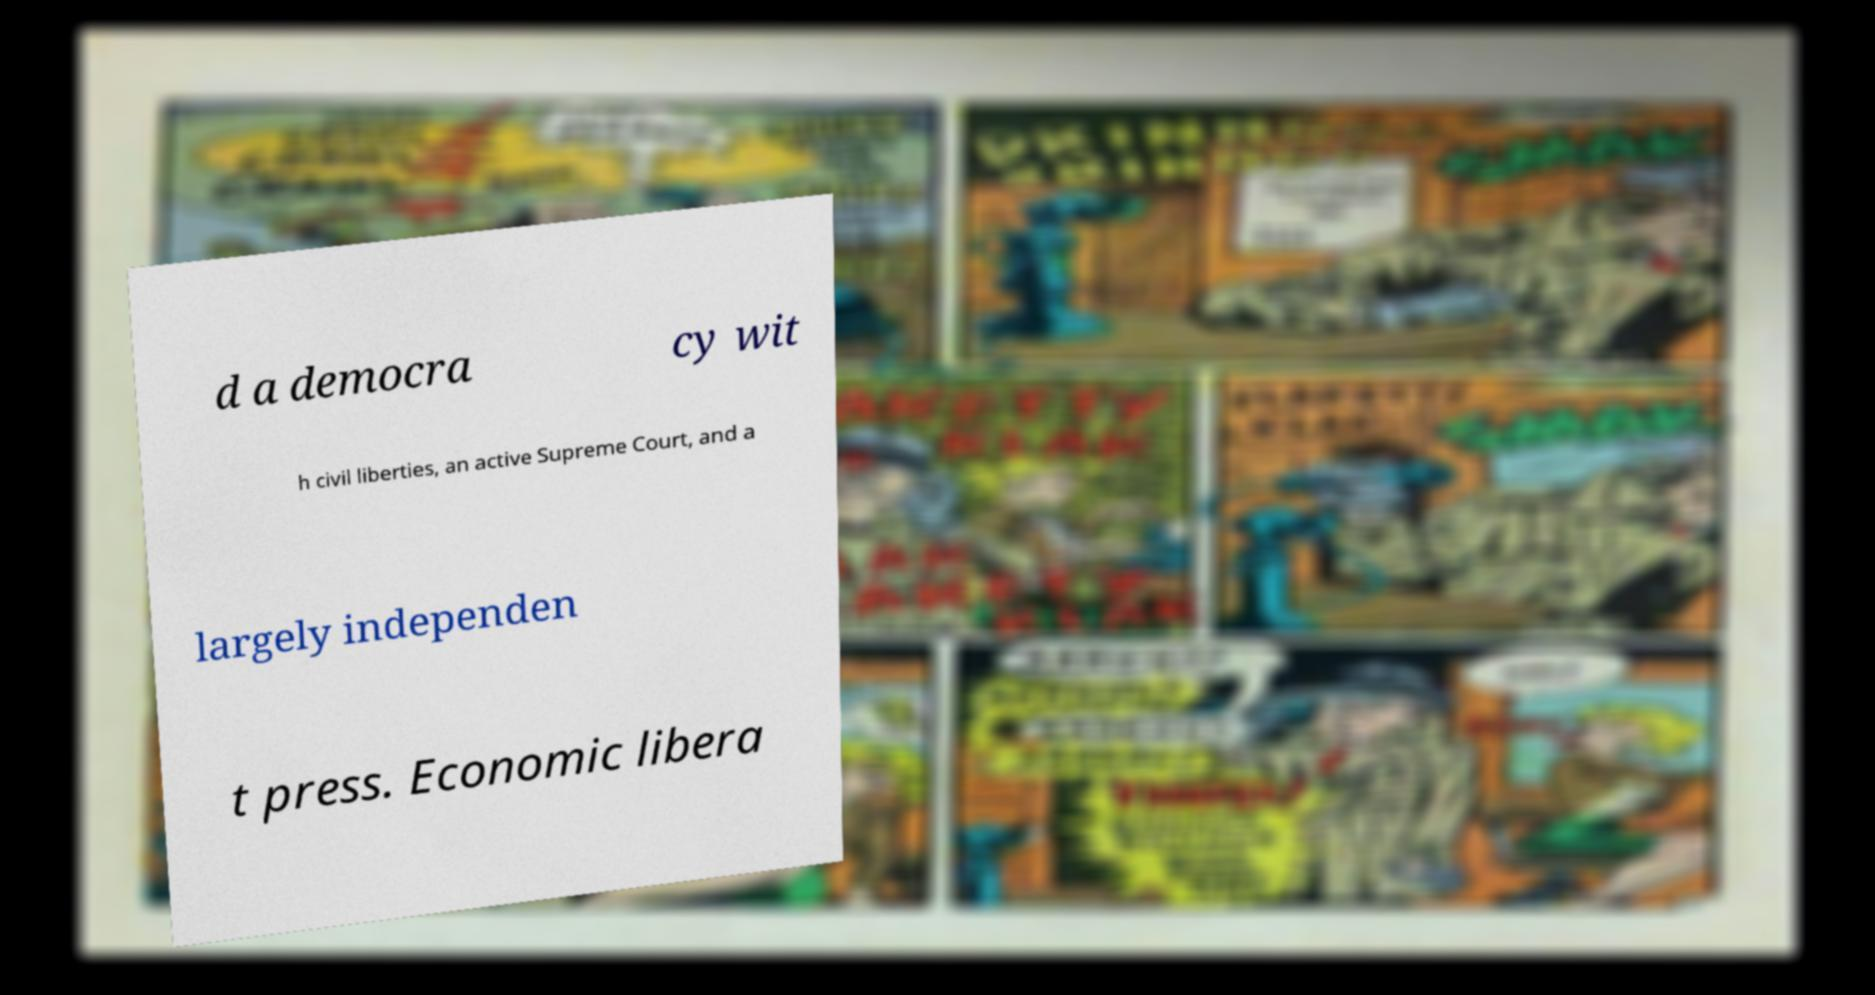Please identify and transcribe the text found in this image. d a democra cy wit h civil liberties, an active Supreme Court, and a largely independen t press. Economic libera 